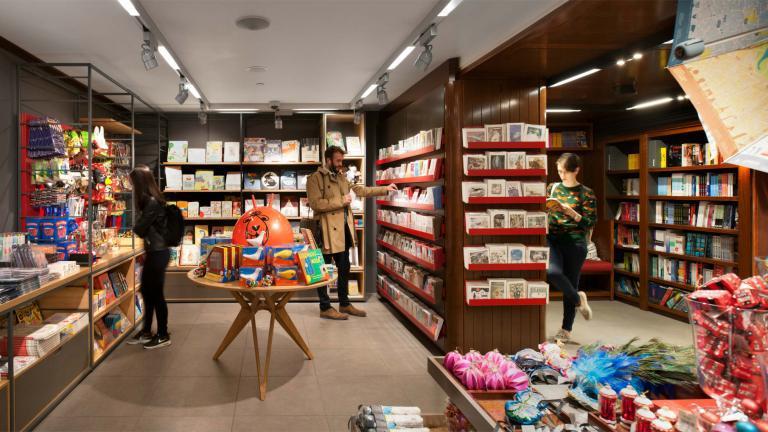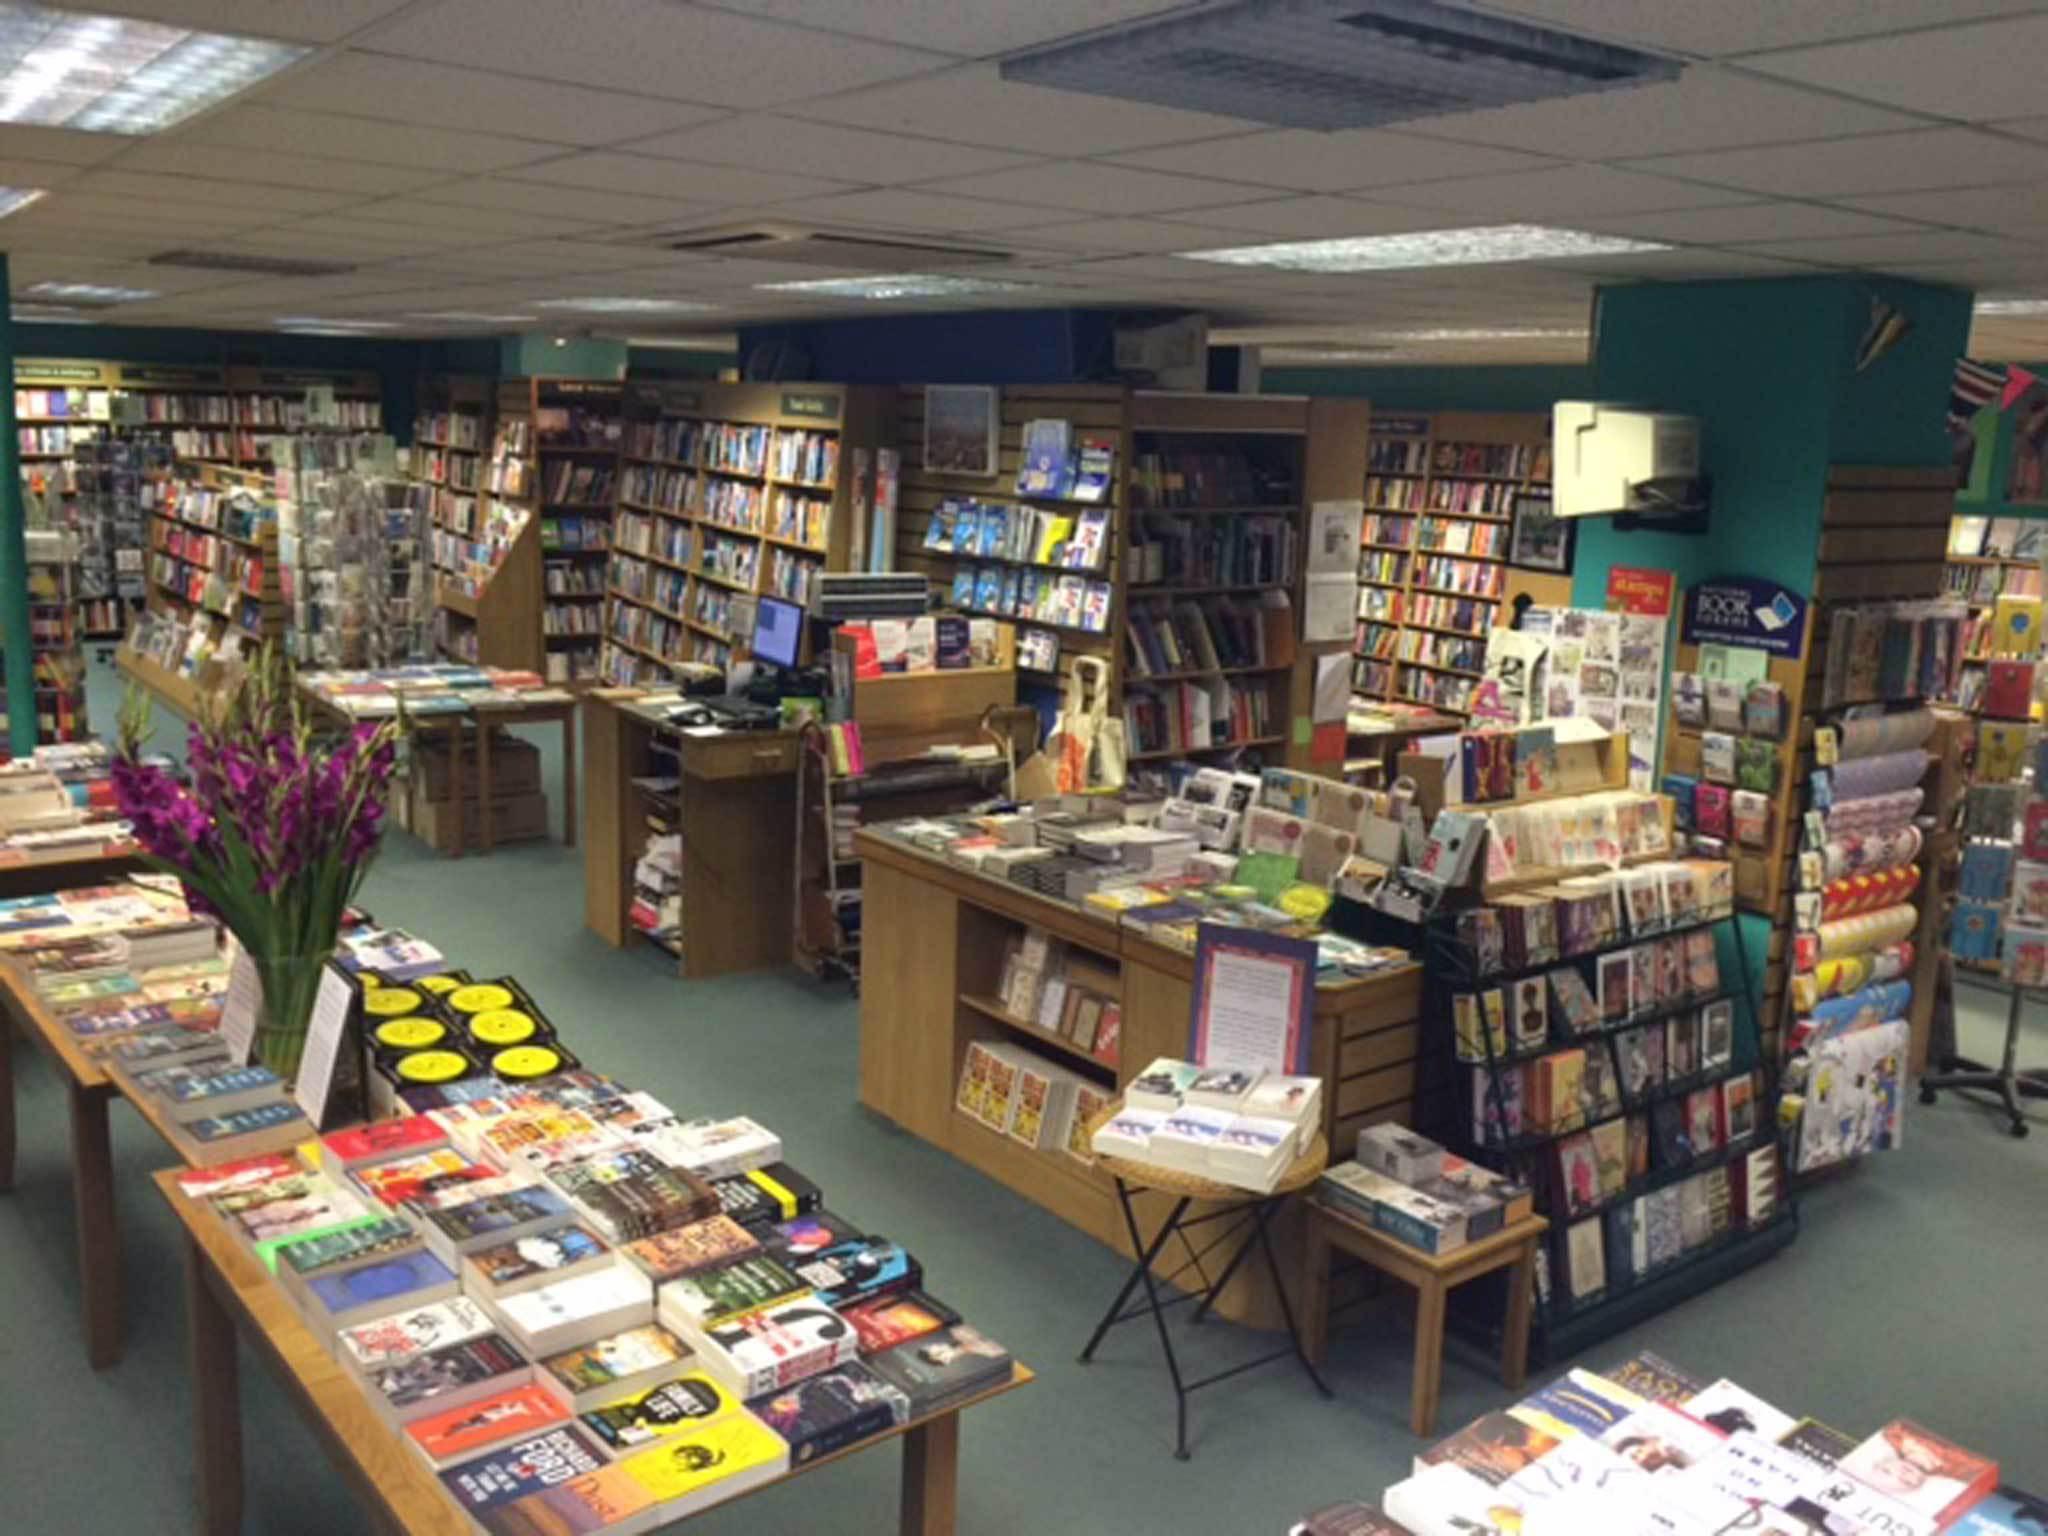The first image is the image on the left, the second image is the image on the right. Assess this claim about the two images: "There is at least one person in the image on the left.". Correct or not? Answer yes or no. Yes. 